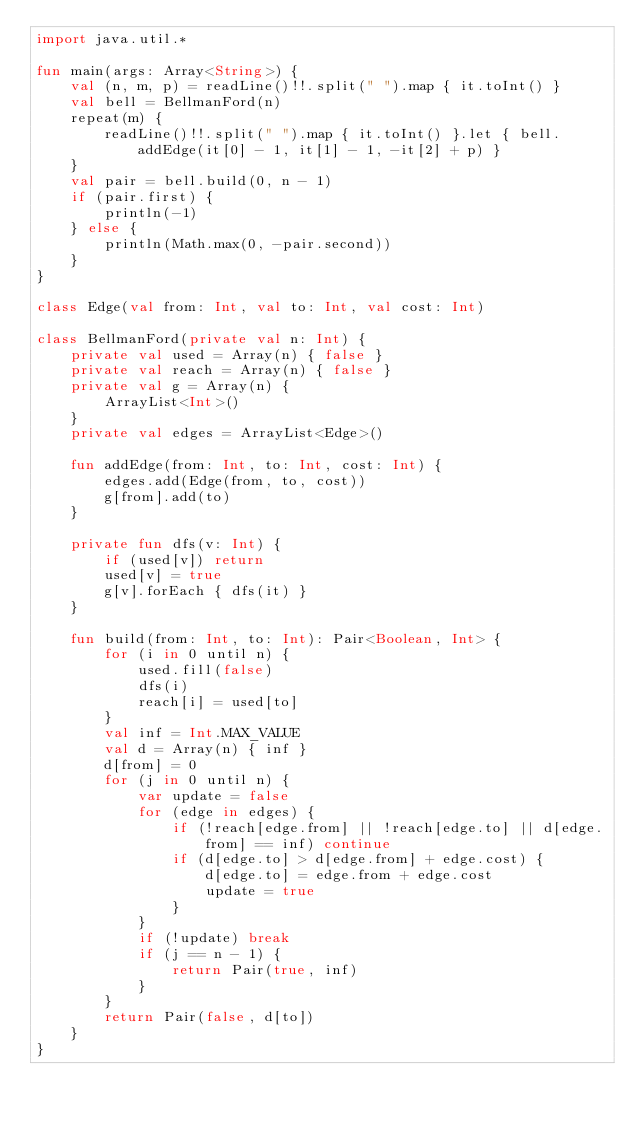<code> <loc_0><loc_0><loc_500><loc_500><_Kotlin_>import java.util.*

fun main(args: Array<String>) {
    val (n, m, p) = readLine()!!.split(" ").map { it.toInt() }
    val bell = BellmanFord(n)
    repeat(m) {
        readLine()!!.split(" ").map { it.toInt() }.let { bell.addEdge(it[0] - 1, it[1] - 1, -it[2] + p) }
    }
    val pair = bell.build(0, n - 1)
    if (pair.first) {
        println(-1)
    } else {
        println(Math.max(0, -pair.second))
    }
}

class Edge(val from: Int, val to: Int, val cost: Int)

class BellmanFord(private val n: Int) {
    private val used = Array(n) { false }
    private val reach = Array(n) { false }
    private val g = Array(n) {
        ArrayList<Int>()
    }
    private val edges = ArrayList<Edge>()

    fun addEdge(from: Int, to: Int, cost: Int) {
        edges.add(Edge(from, to, cost))
        g[from].add(to)
    }

    private fun dfs(v: Int) {
        if (used[v]) return
        used[v] = true
        g[v].forEach { dfs(it) }
    }

    fun build(from: Int, to: Int): Pair<Boolean, Int> {
        for (i in 0 until n) {
            used.fill(false)
            dfs(i)
            reach[i] = used[to]
        }
        val inf = Int.MAX_VALUE
        val d = Array(n) { inf }
        d[from] = 0
        for (j in 0 until n) {
            var update = false
            for (edge in edges) {
                if (!reach[edge.from] || !reach[edge.to] || d[edge.from] == inf) continue
                if (d[edge.to] > d[edge.from] + edge.cost) {
                    d[edge.to] = edge.from + edge.cost
                    update = true
                }
            }
            if (!update) break
            if (j == n - 1) {
                return Pair(true, inf)
            }
        }
        return Pair(false, d[to])
    }
}</code> 